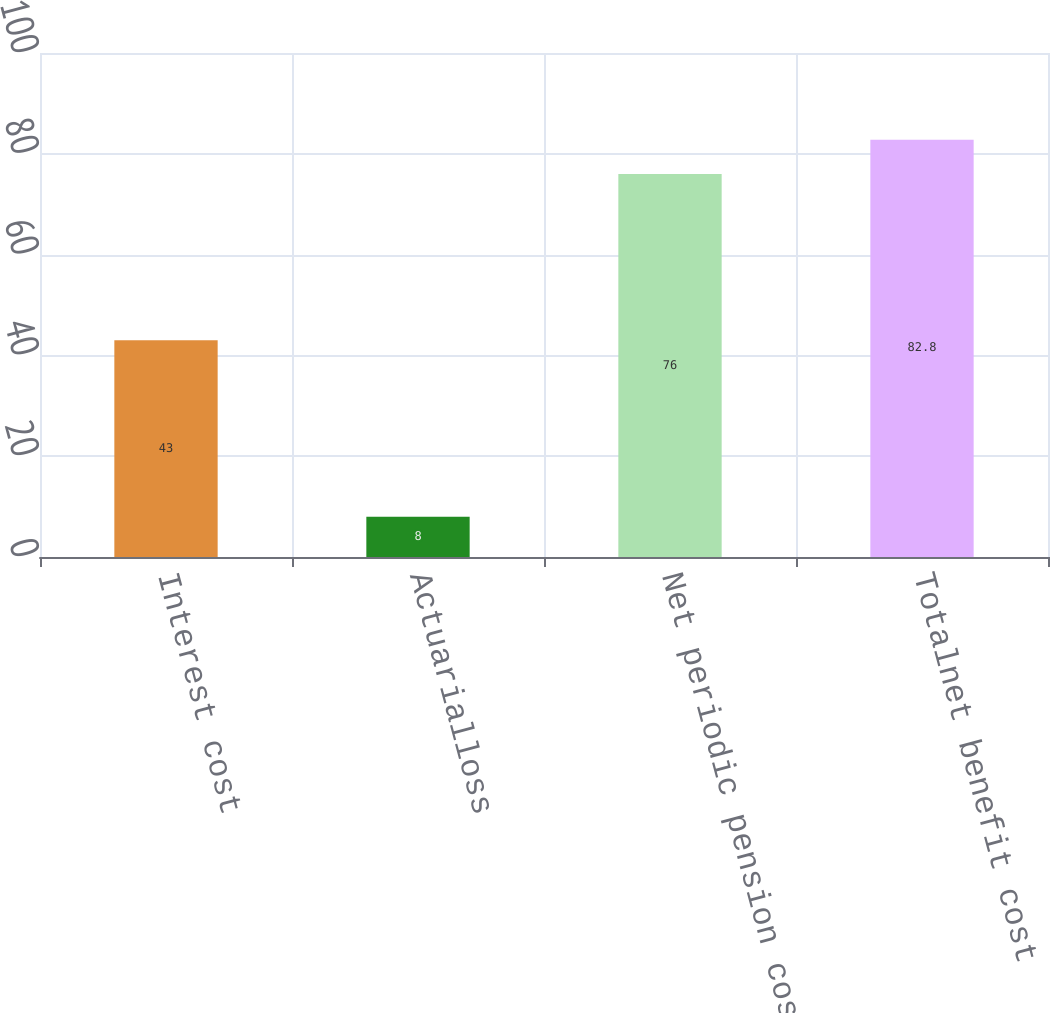Convert chart to OTSL. <chart><loc_0><loc_0><loc_500><loc_500><bar_chart><fcel>Interest cost<fcel>Actuarialloss<fcel>Net periodic pension cost<fcel>Totalnet benefit cost<nl><fcel>43<fcel>8<fcel>76<fcel>82.8<nl></chart> 